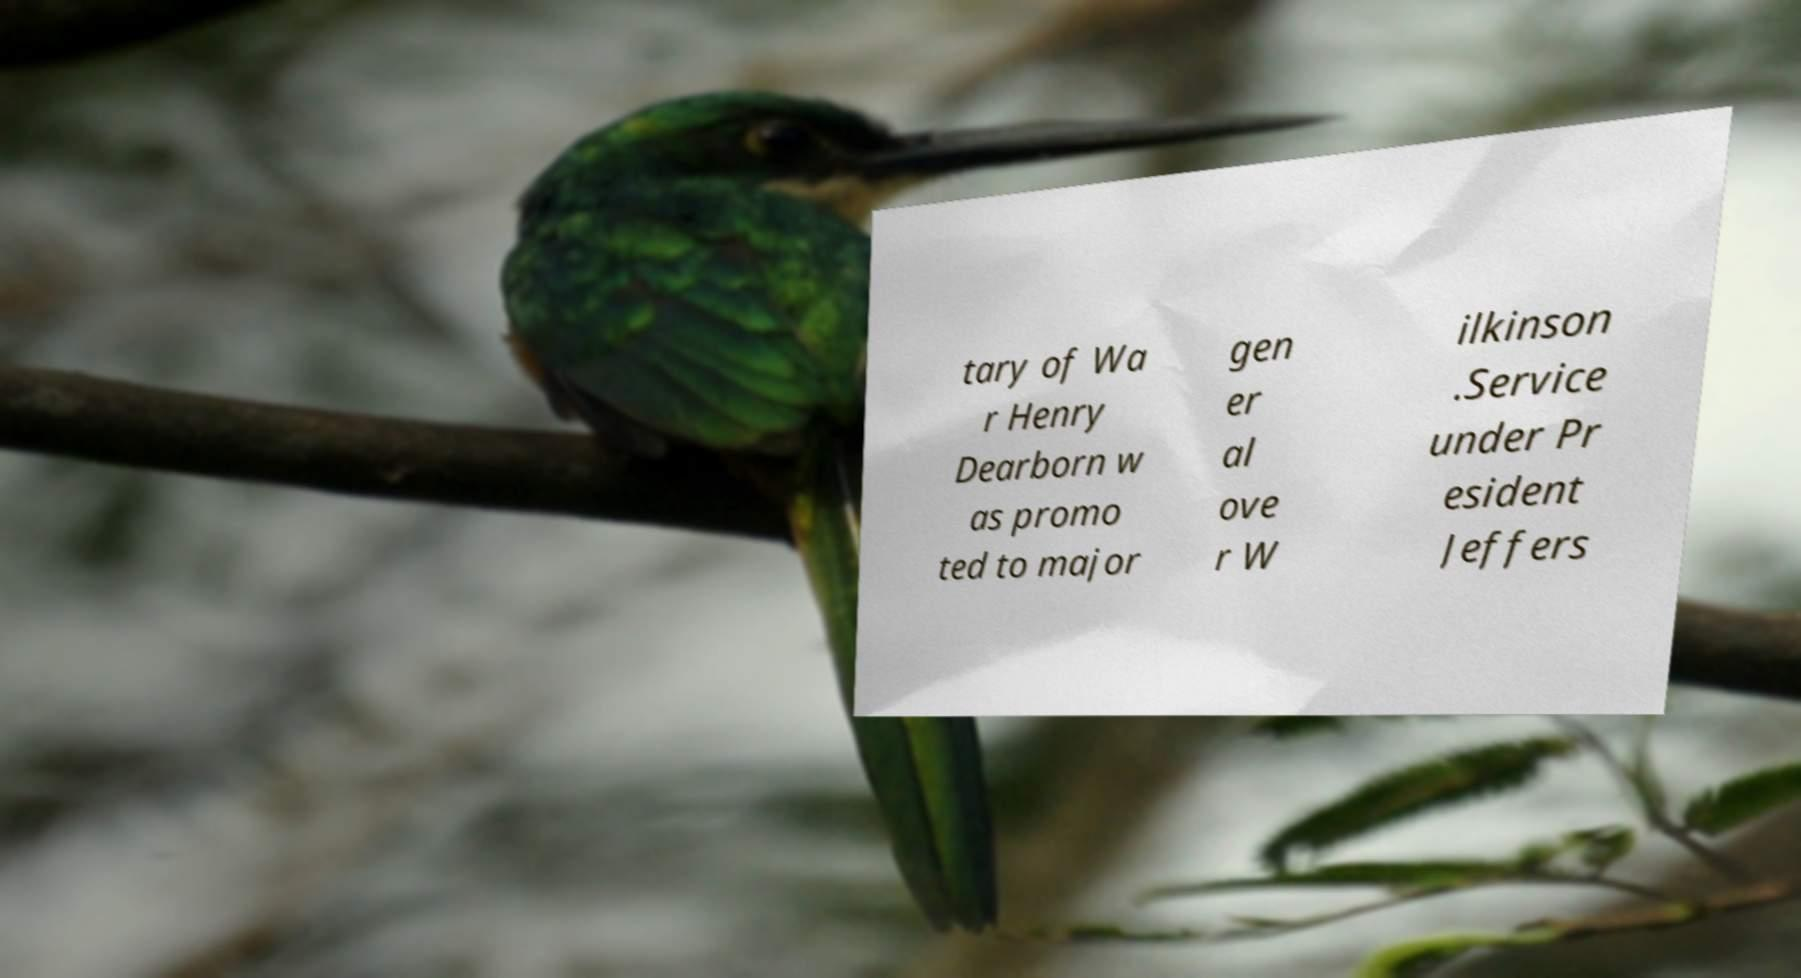Please read and relay the text visible in this image. What does it say? tary of Wa r Henry Dearborn w as promo ted to major gen er al ove r W ilkinson .Service under Pr esident Jeffers 